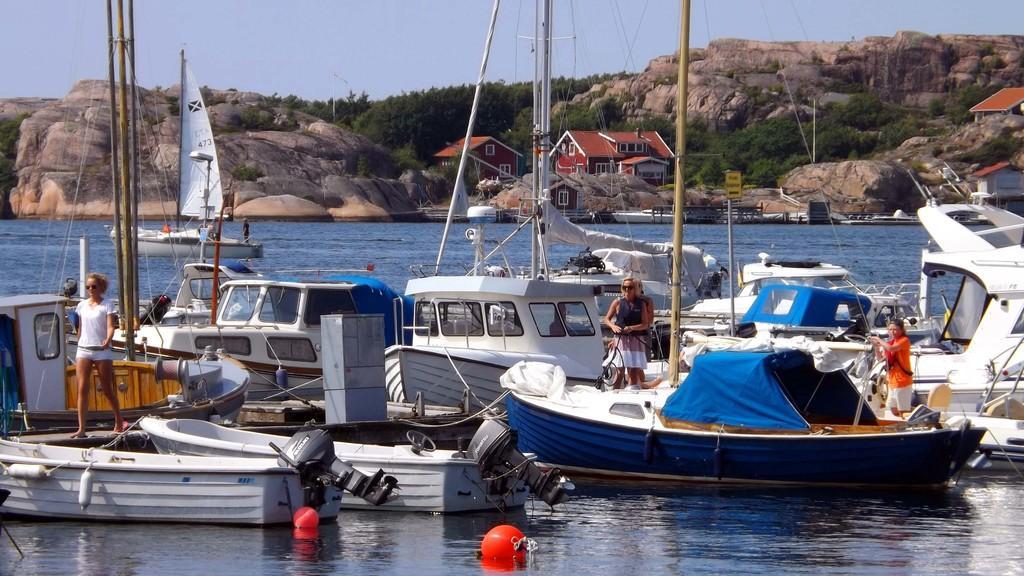Could you give a brief overview of what you see in this image? In this image there are boats on the water. On the boats there are a few people standing. In the background there are rocky mountains and trees. There are houses between the mountains. At the top there is the sky. At the bottom there is the water. 